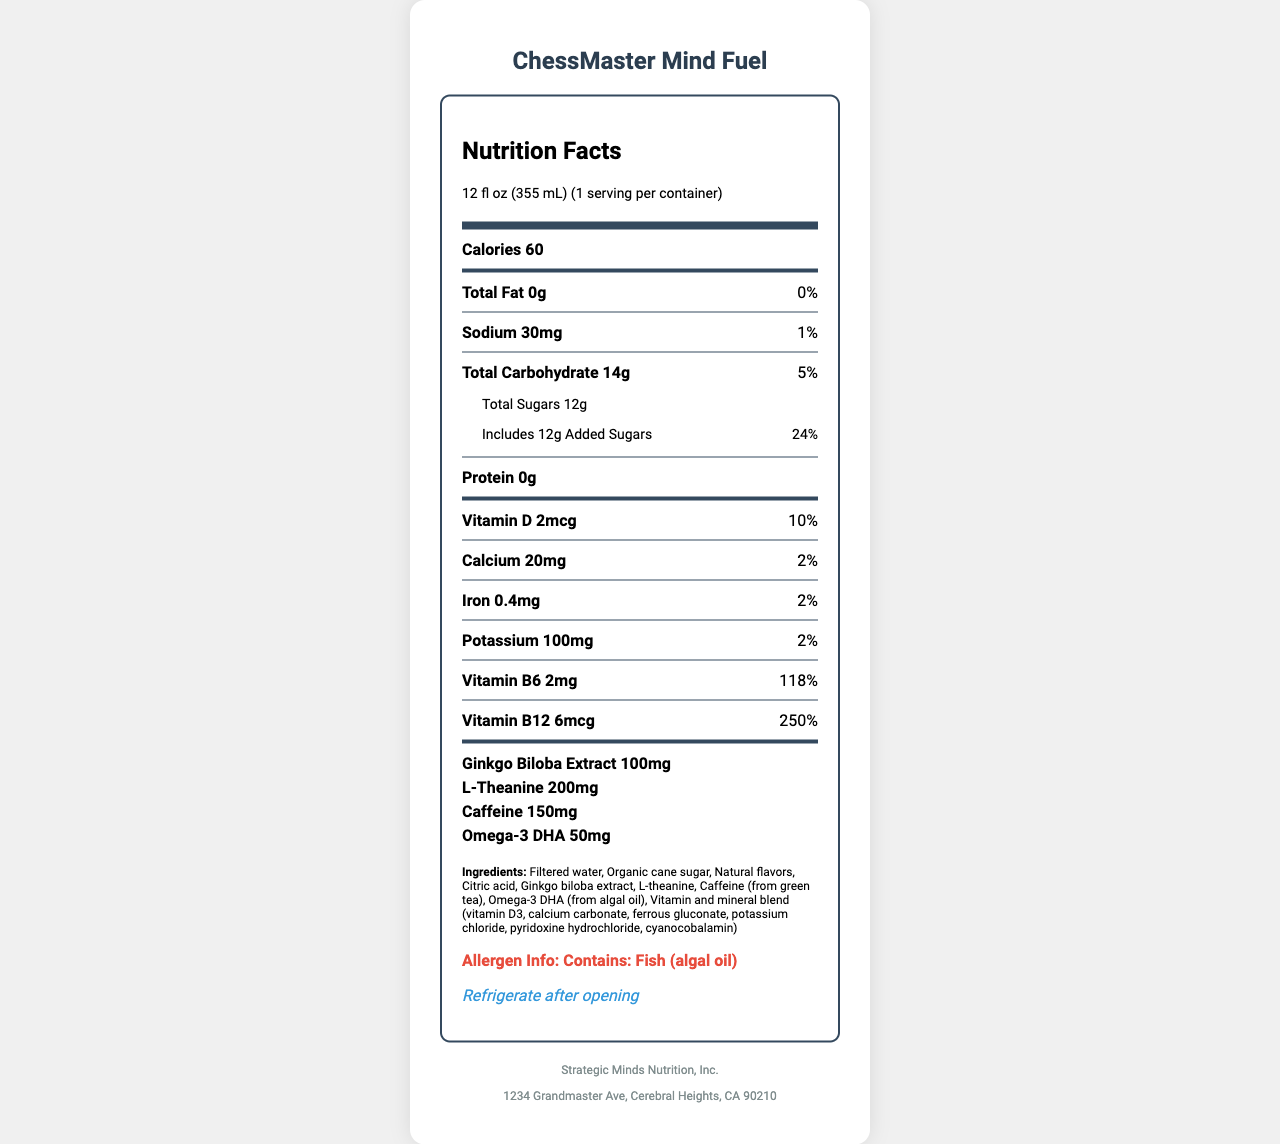how many calories are in one serving of ChessMaster Mind Fuel? The document lists the calorie content as 60 calories per serving.
Answer: 60 what is the serving size of ChessMaster Mind Fuel in milliliters? The serving size is given as 12 fl oz (355 mL).
Answer: 355 mL how much protein is in a serving of ChessMaster Mind Fuel? The document states that there is 0g of protein in a serving.
Answer: 0g what percentage of the daily value of Vitamin B12 does one serving provide? The document states that one serving provides 250% of the daily value of Vitamin B12.
Answer: 250% does ChessMaster Mind Fuel contain any added sugars? The document notes that the total sugars include 12g of added sugars, which is 24% of the daily value.
Answer: Yes what are the main ingredients in ChessMaster Mind Fuel? A. Water, Sugar, Artificial Flavors B. Filtered water, Organic cane sugar, Natural flavors C. Alcohol, Ginkgo Biloba Extract, Caffeine D. Artificial ingredients and preservatives The document lists the main ingredients as Filtered water, Organic cane sugar, Natural flavors.
Answer: B which nutrient has the highest daily value percentage in ChessMaster Mind Fuel? A. Vitamin D B. Vitamin B6 C. Vitamin B12 D. Potassium Vitamin B12 has the highest daily value percentage at 250%.
Answer: C does ChessMaster Mind Fuel contain any allergens? The allergen information states that the product contains fish (algal oil).
Answer: Yes summarize the main idea of the document. The document provides a comprehensive overview of the nutritional content, ingredients, and other relevant information for ChessMaster Mind Fuel.
Answer: The document is a nutrition facts label for ChessMaster Mind Fuel, detailing the serving size, nutritional content per serving, ingredients, allergen information, and storage instructions. The beverage is vitamin-fortified to support cognitive function and focus, containing various vitamins, minerals, ginkgo biloba extract, L-theanine, caffeine, and omega-3 DHA. what is the recommended storage condition after opening? The document specifies that the beverage should be refrigerated after opening.
Answer: Refrigerate after opening how much L-theanine is present in one serving of ChessMaster Mind Fuel? The document lists the amount of L-theanine as 200mg per serving.
Answer: 200mg which vitamin in ChessMaster Mind Fuel is included at just 2% of the daily value? The document shows that Calcium is included at 2% of the daily value.
Answer: Calcium how many servings are contained in one container of ChessMaster Mind Fuel? The document indicates that there is 1 serving per container.
Answer: 1 does the beverage include caffeine along with its ingredient description? The document mentions that the caffeine in the beverage comes from green tea.
Answer: Yes, Caffeine from green tea who is the manufacturer of ChessMaster Mind Fuel? The document lists the manufacturer as Strategic Minds Nutrition, Inc.
Answer: Strategic Minds Nutrition, Inc. can you determine the exact source of omega-3 DHA in the product? The document specifies that the omega-3 DHA is sourced from algal oil.
Answer: Yes, Algal oil are there any artificial preservatives listed in the ingredients? The ingredients list does not mention any artificial preservatives.
Answer: No where is the manufacturing address of ChessMaster Mind Fuel located? The document provides the manufacturing address at 1234 Grandmaster Ave, Cerebral Heights, CA 90210.
Answer: 1234 Grandmaster Ave, Cerebral Heights, CA 90210 how much iron does one serving of ChessMaster Mind Fuel contain? The document states that one serving contains 0.4mg of iron.
Answer: 0.4mg compare the daily value percentages of sodium and total carbohydrate. The document lists the daily value percentage for sodium as 1% and for total carbohydrate as 5%.
Answer: Sodium: 1%, Total Carbohydrate: 5% what is the primary health benefit of ChessMaster Mind Fuel as suggested by the product name and nutritional content? The product name "ChessMaster Mind Fuel" and the inclusion of cognitive-supporting ingredients like ginkgo biloba extract, L-theanine, and caffeine suggest it is formulated to support cognitive function and focus.
Answer: Supports cognitive function and focus 